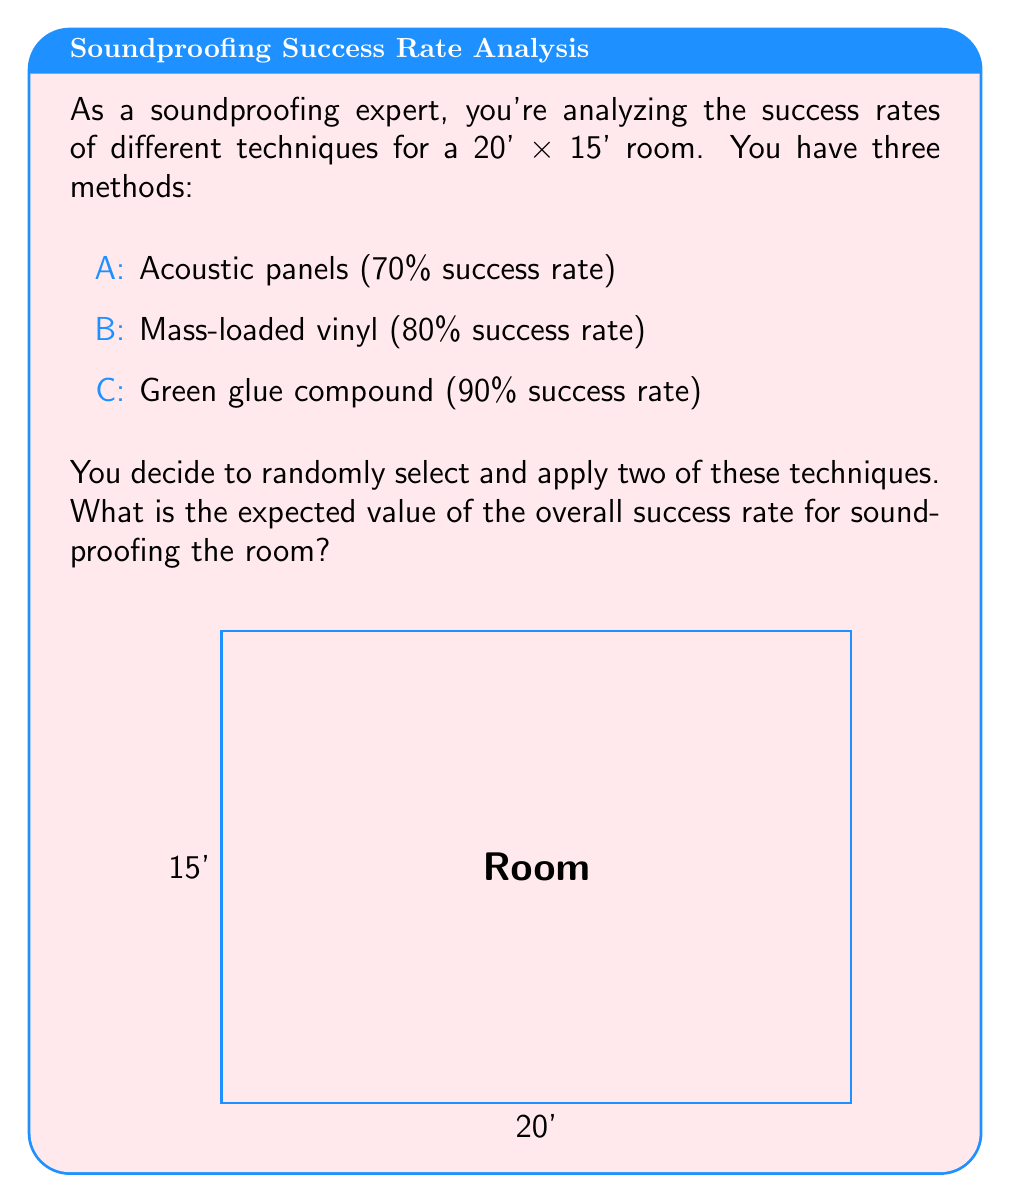Give your solution to this math problem. Let's approach this step-by-step:

1) First, we need to calculate the probability of selecting each possible combination:
   (A,B), (A,C), or (B,C). Each has a $\frac{1}{3}$ chance of being selected.

2) For each combination, we need to calculate the overall success rate:

   For (A,B): $1 - (1-0.7)(1-0.8) = 1 - 0.3 \times 0.2 = 1 - 0.06 = 0.94$ or 94%
   For (A,C): $1 - (1-0.7)(1-0.9) = 1 - 0.3 \times 0.1 = 1 - 0.03 = 0.97$ or 97%
   For (B,C): $1 - (1-0.8)(1-0.9) = 1 - 0.2 \times 0.1 = 1 - 0.02 = 0.98$ or 98%

3) Now, we can calculate the expected value:

   $$E = \frac{1}{3} \times 0.94 + \frac{1}{3} \times 0.97 + \frac{1}{3} \times 0.98$$

4) Simplifying:

   $$E = \frac{0.94 + 0.97 + 0.98}{3} = \frac{2.89}{3} \approx 0.9633$$

5) Converting to a percentage:

   $$0.9633 \times 100\% \approx 96.33\%$$

Therefore, the expected value of the overall success rate is approximately 96.33%.
Answer: 96.33% 